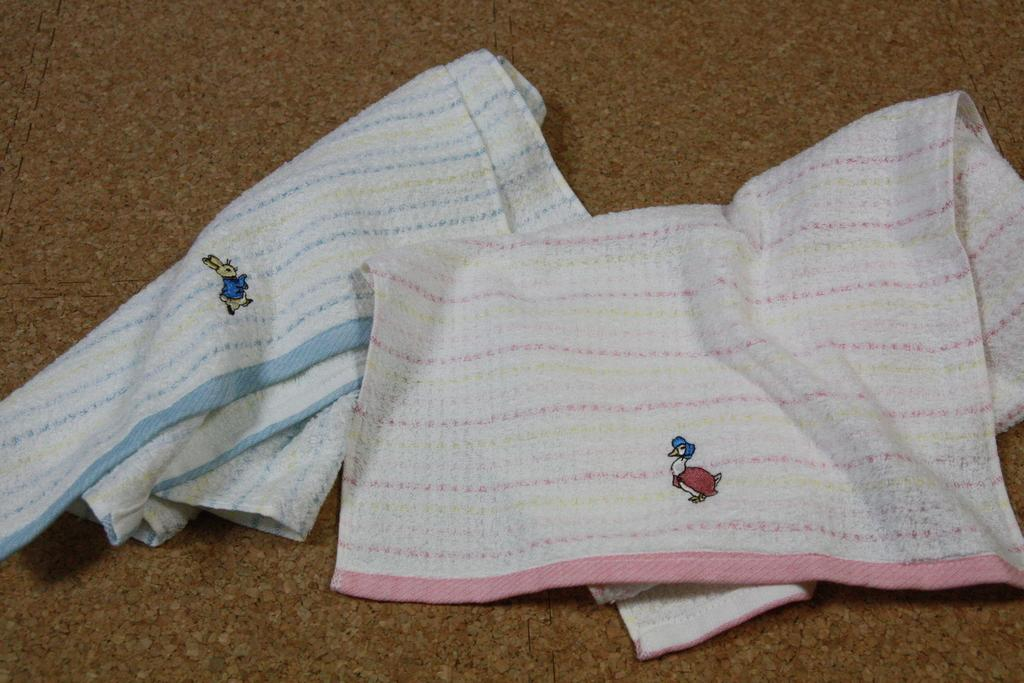What color are the clothes that are visible in the image? The clothes in the image are white. Where are the white clothes placed in the image? The white clothes are placed on a surface. What type of design can be seen on the white clothes? There is embroidery work visible on the white clothes. What type of flight is depicted on the white clothes in the image? There is no flight depicted on the white clothes in the image; it features embroidery work instead. 